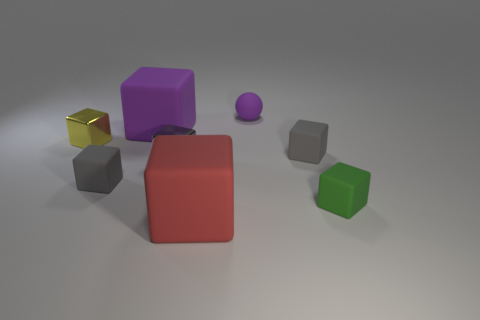Subtract all cyan balls. How many gray cubes are left? 3 Subtract 4 blocks. How many blocks are left? 3 Subtract all gray blocks. How many blocks are left? 4 Subtract all yellow metallic blocks. How many blocks are left? 6 Subtract all blue blocks. Subtract all gray spheres. How many blocks are left? 7 Add 2 large red shiny cylinders. How many objects exist? 10 Subtract all balls. How many objects are left? 7 Subtract 0 brown spheres. How many objects are left? 8 Subtract all big red cubes. Subtract all green matte objects. How many objects are left? 6 Add 6 tiny gray matte things. How many tiny gray matte things are left? 8 